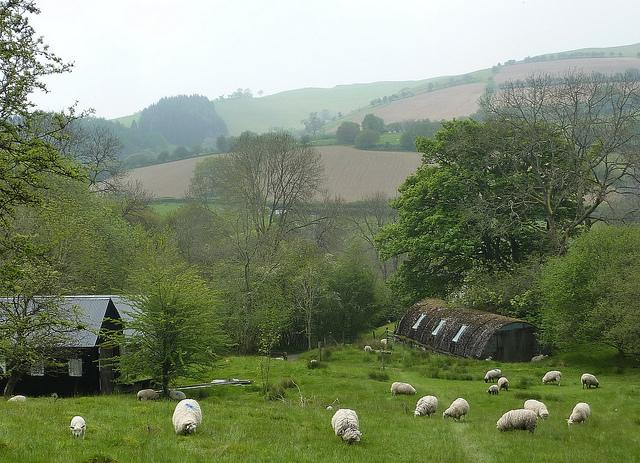What building material is the longhouse next to the sheep?

Choices:
A) mud
B) straw
C) sticks
D) brick sticks 